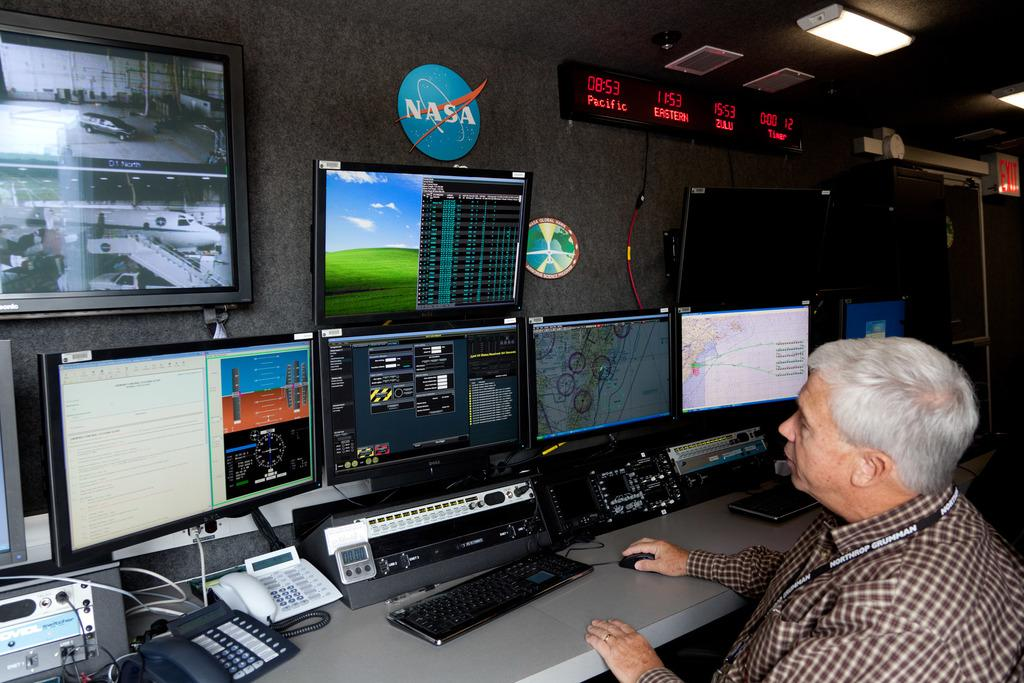Provide a one-sentence caption for the provided image. A man sitting in front of a bank of computer monitors with a NASA sign on the wall above them. 